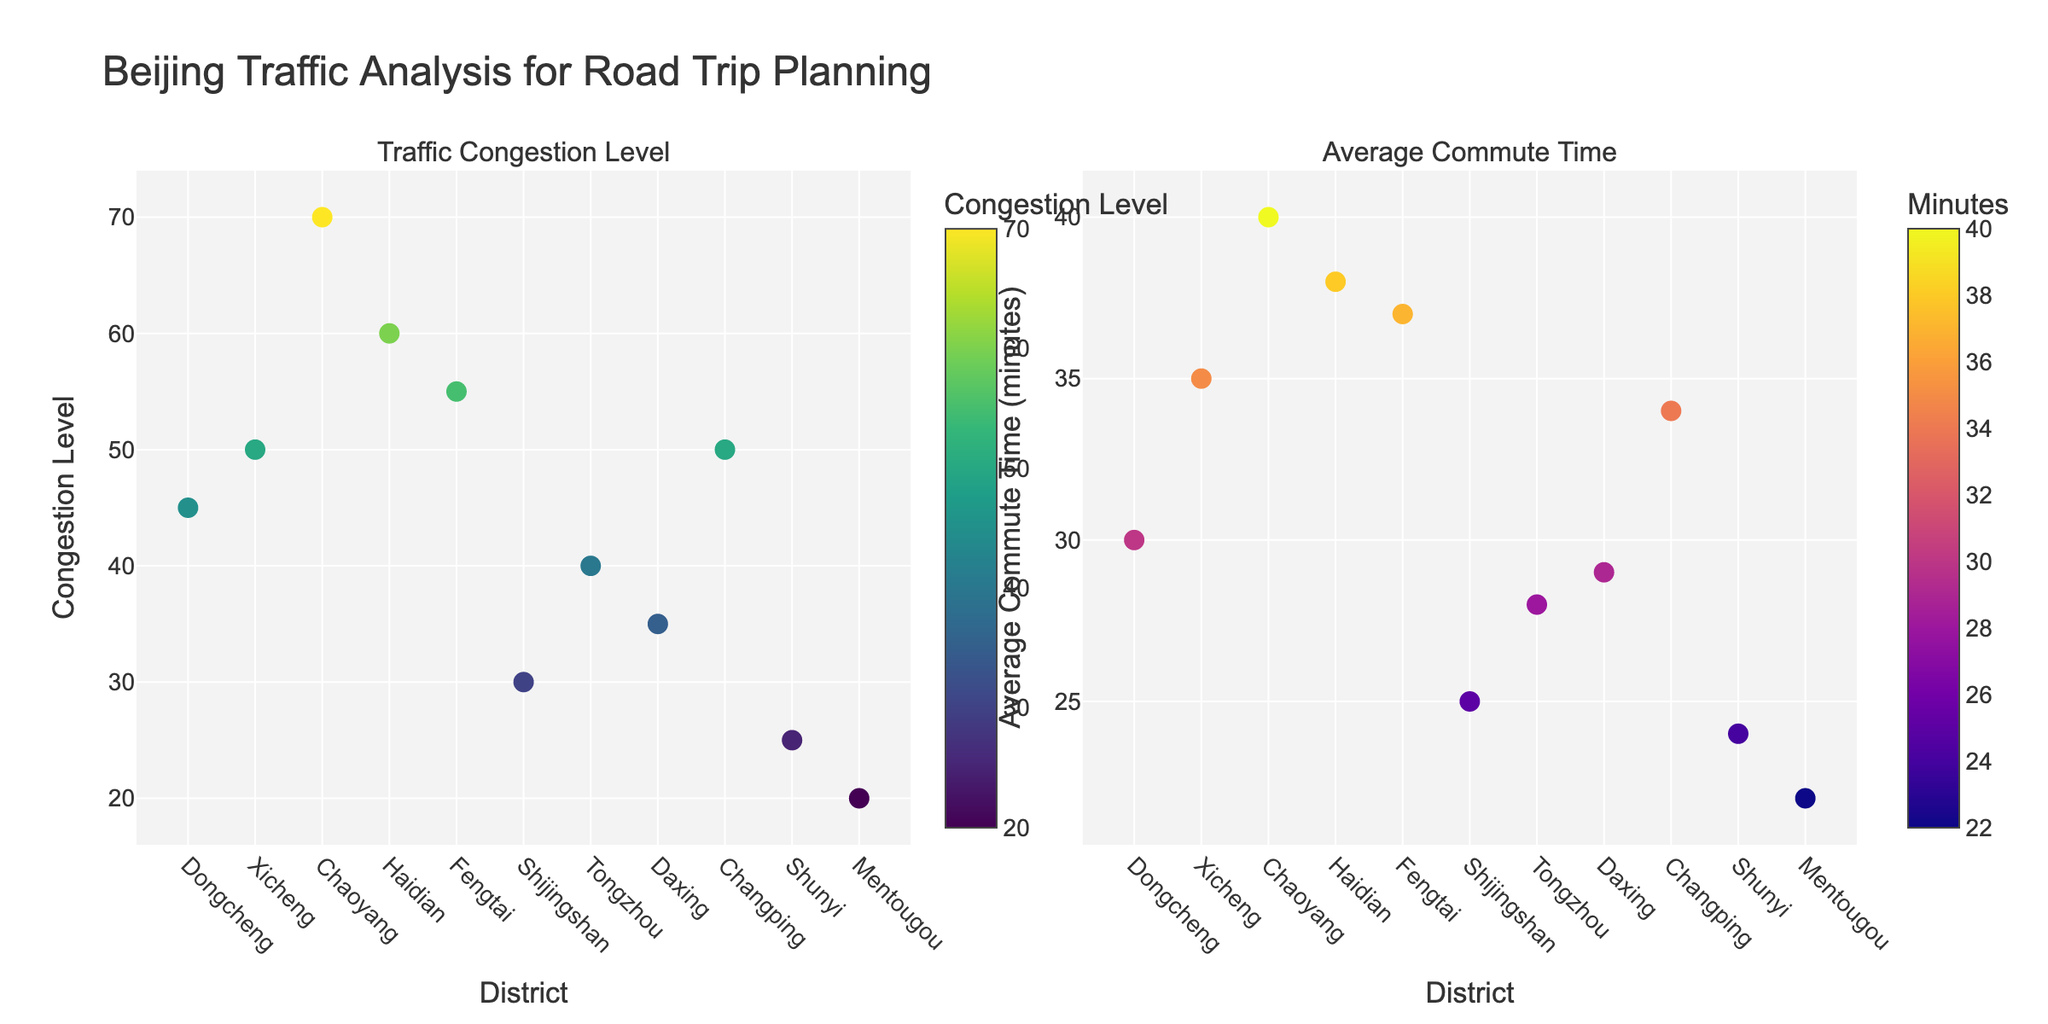How many districts are plotted in the figure? There are a total of 11 districts plotted in both subplots (Dongcheng, Xicheng, Chaoyang, Haidian, Fengtai, Shijingshan, Tongzhou, Daxing, Changping, Shunyi, and Mentougou)
Answer: 11 Which district has the highest traffic congestion level? The district with the highest traffic congestion level can be identified by finding the tallest marker in the left subplot. Chaoyang has a congestion level of 70, which is the highest.
Answer: Chaoyang What is the average commute time in Mentougou? To find the average commute time for Mentougou, look at the marker labeled 'Mentougou' in the right subplot. The corresponding y-value for Mentougou is 22 minutes.
Answer: 22 Which district has the lowest average commute time, and what is it? In the right subplot, identify the marker with the smallest y-value. Shunyi has the lowest average commute time, which is 24 minutes.
Answer: Shunyi, 24 Is there any district where the traffic congestion level is greater than 60? Look at the left subplot and see which markers are above the y=60 line. Chaoyang has a congestion level of 70, which is greater than 60.
Answer: Yes, Chaoyang Compare the average commute times between Haidian and Fengtai. Which one is higher and by how much? Look at the y-values for Haidian and Fengtai in the right subplot. Haidian has a commute time of 38 minutes, and Fengtai has 37 minutes. Haidian's commute time is higher by 1 minute.
Answer: Haidian, by 1 minute Determine the district with both traffic congestion level less than 30 and the average commute time less than 25 minutes. Check both subplots for markers that meet both conditions. Mentougou has a congestion level of 20 and an average commute time of 22, fulfilling both criteria.
Answer: Mentougou Which districts have traffic congestion levels between 40 and 60? In the left subplot, locate markers within the range of y-values 40 to 60. The districts are Dongcheng (45), Xicheng (50), Fengtai (55), and Changping (50).
Answer: Dongcheng, Xicheng, Fengtai, Changping 